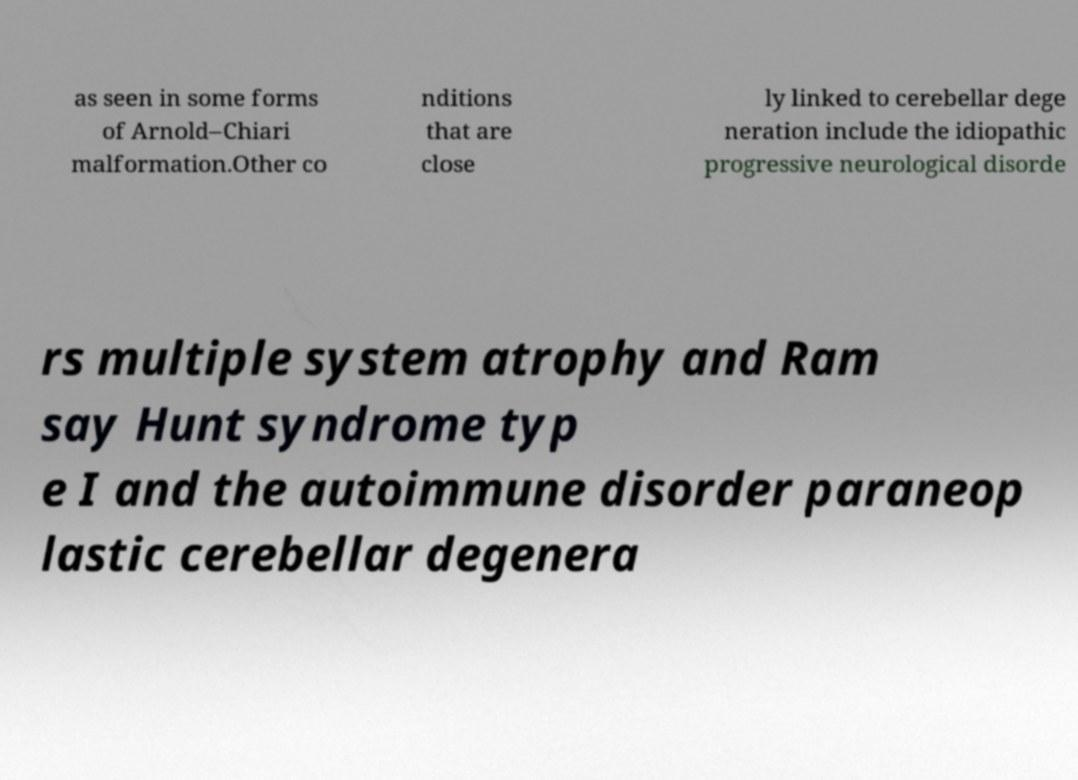Could you assist in decoding the text presented in this image and type it out clearly? as seen in some forms of Arnold–Chiari malformation.Other co nditions that are close ly linked to cerebellar dege neration include the idiopathic progressive neurological disorde rs multiple system atrophy and Ram say Hunt syndrome typ e I and the autoimmune disorder paraneop lastic cerebellar degenera 